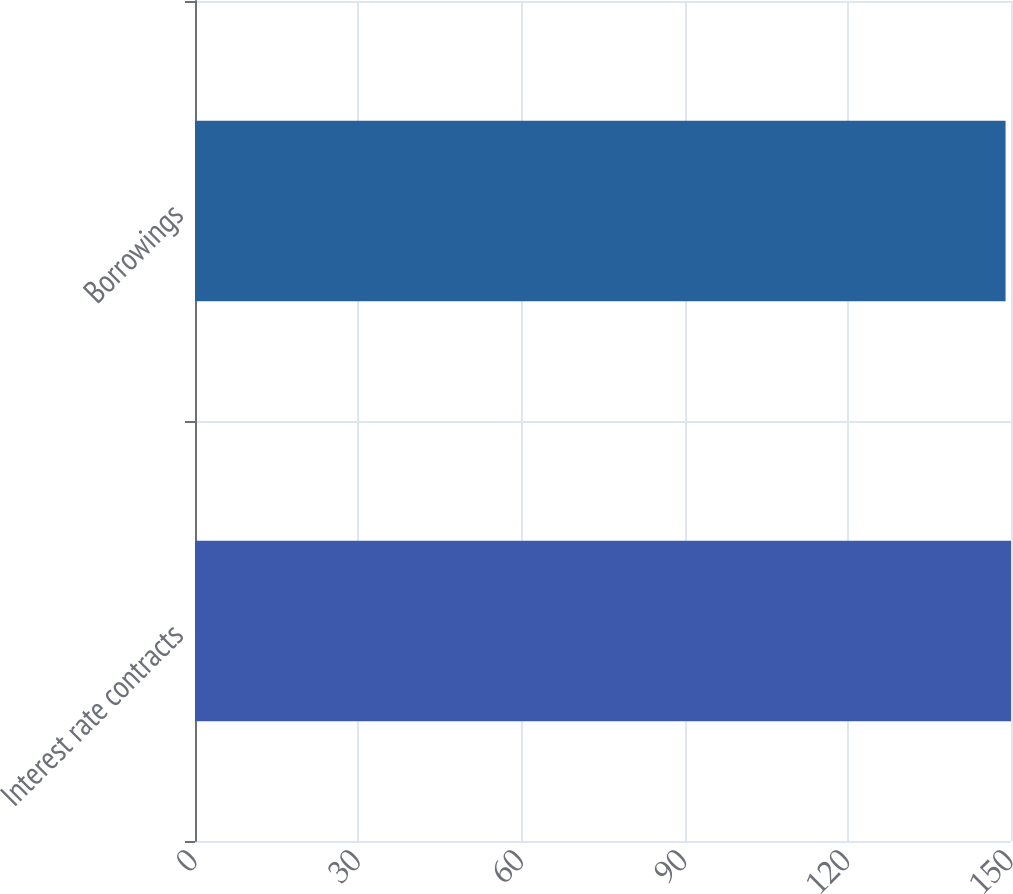Convert chart to OTSL. <chart><loc_0><loc_0><loc_500><loc_500><bar_chart><fcel>Interest rate contracts<fcel>Borrowings<nl><fcel>150<fcel>149<nl></chart> 